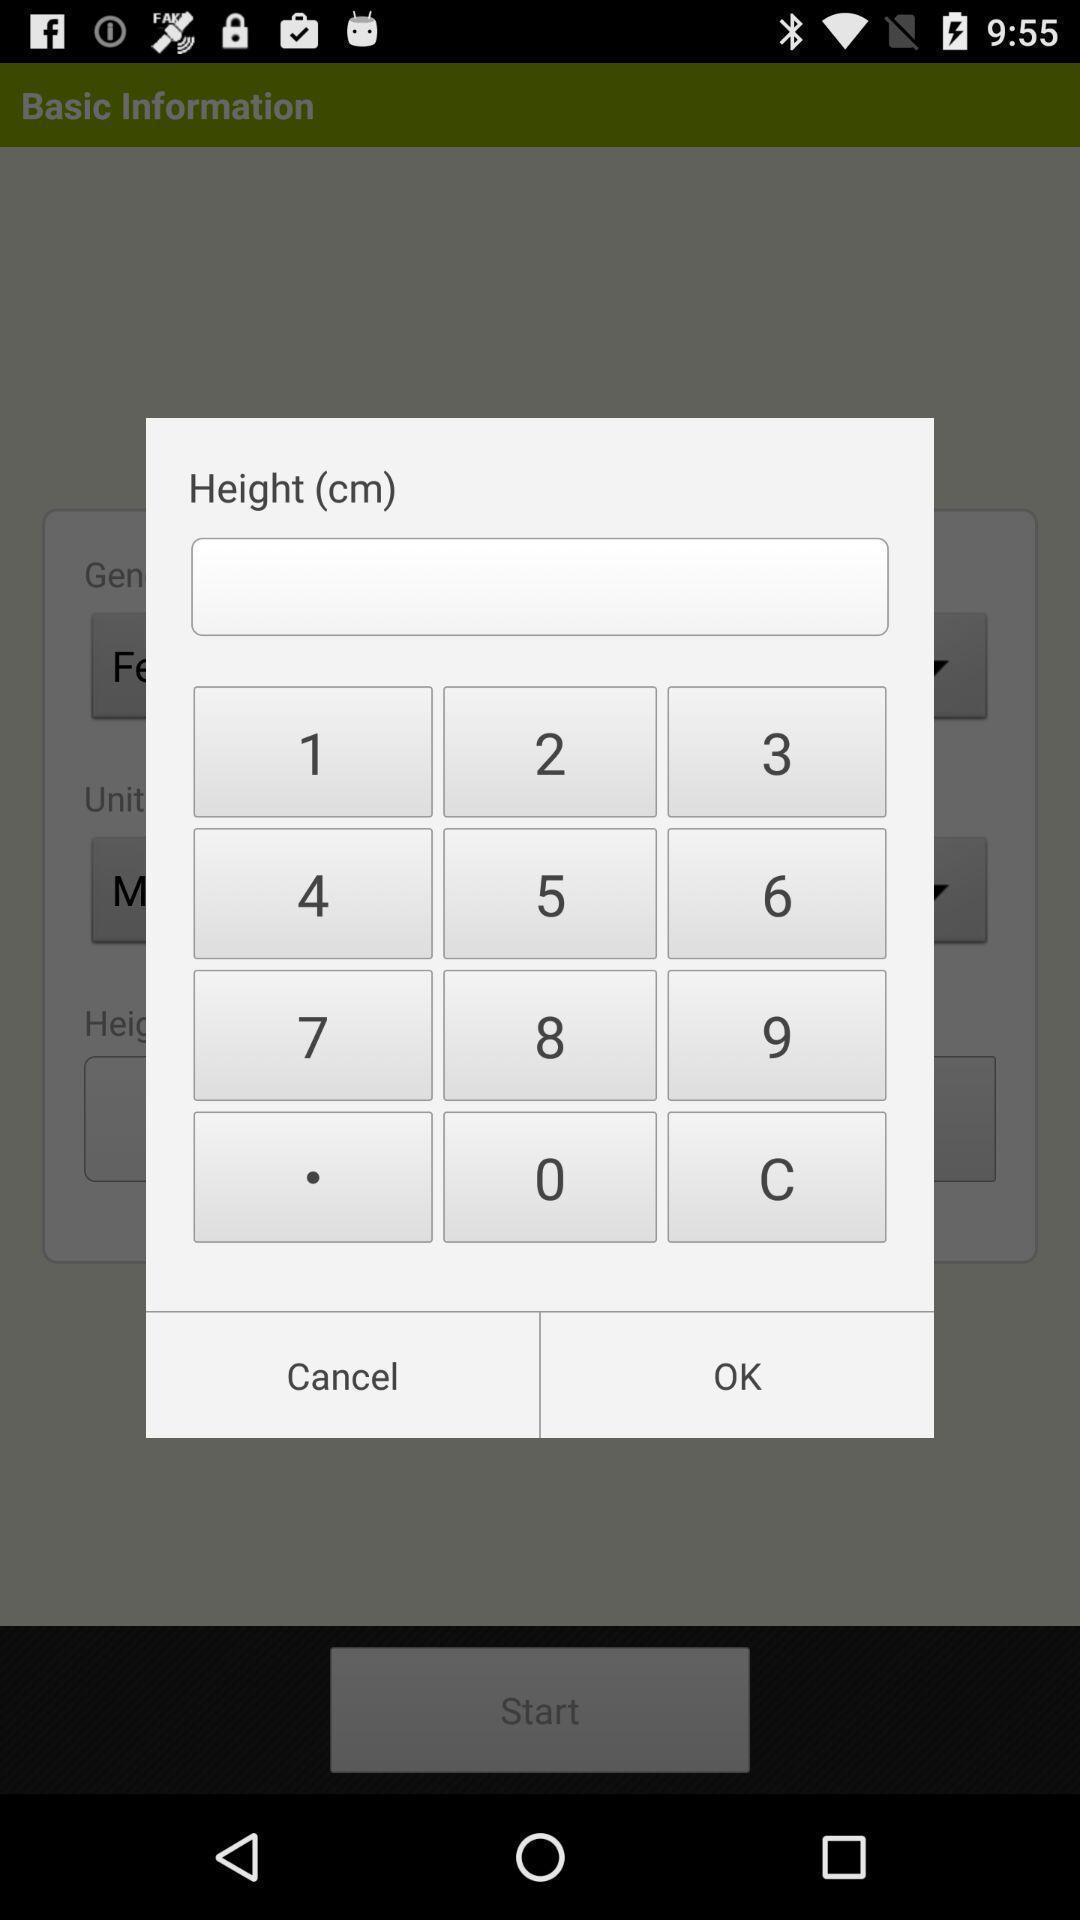Explain the elements present in this screenshot. Pop-up showing different digits to enter. 